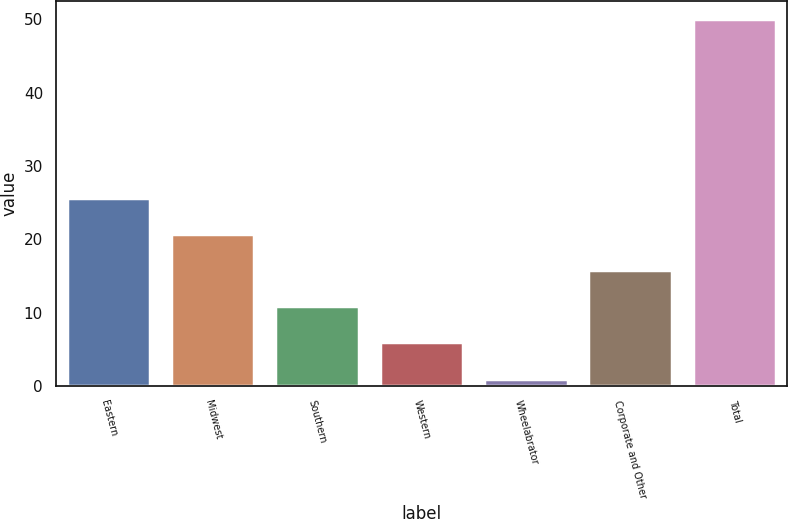<chart> <loc_0><loc_0><loc_500><loc_500><bar_chart><fcel>Eastern<fcel>Midwest<fcel>Southern<fcel>Western<fcel>Wheelabrator<fcel>Corporate and Other<fcel>Total<nl><fcel>25.6<fcel>20.7<fcel>10.9<fcel>6<fcel>1<fcel>15.8<fcel>50<nl></chart> 